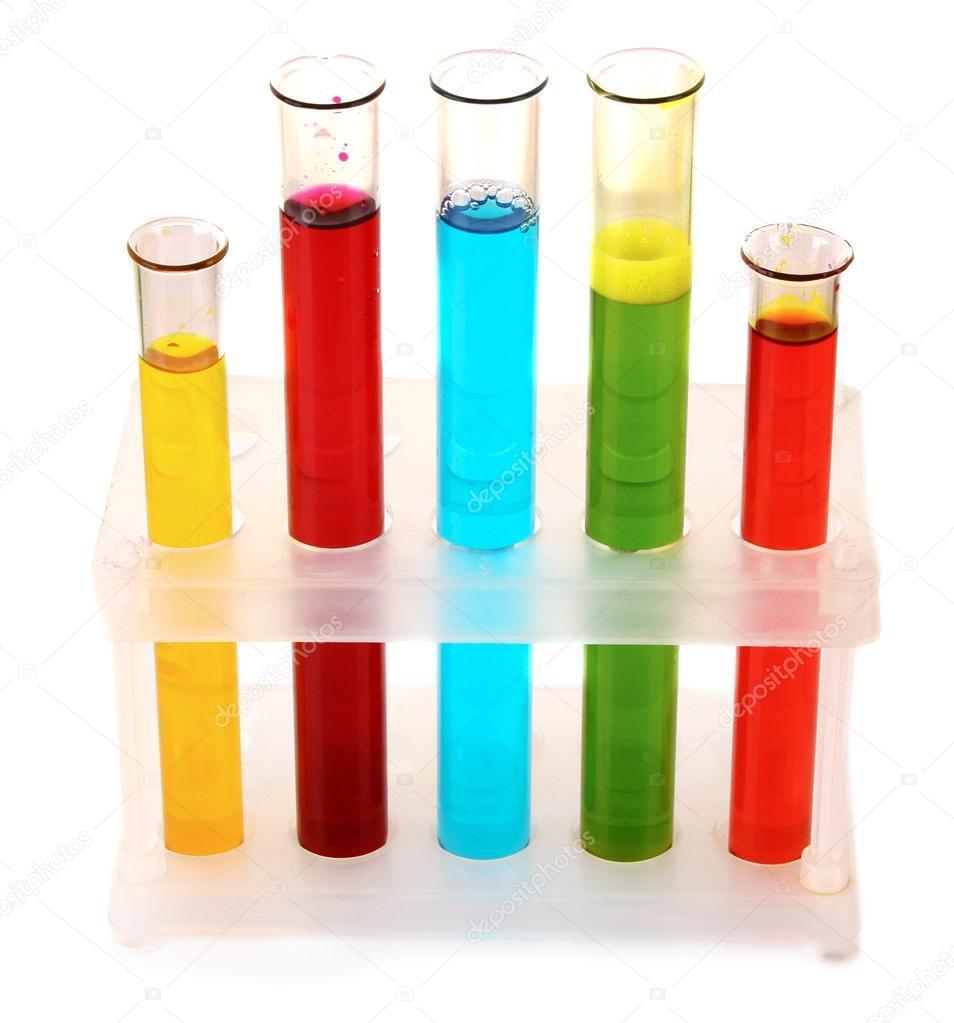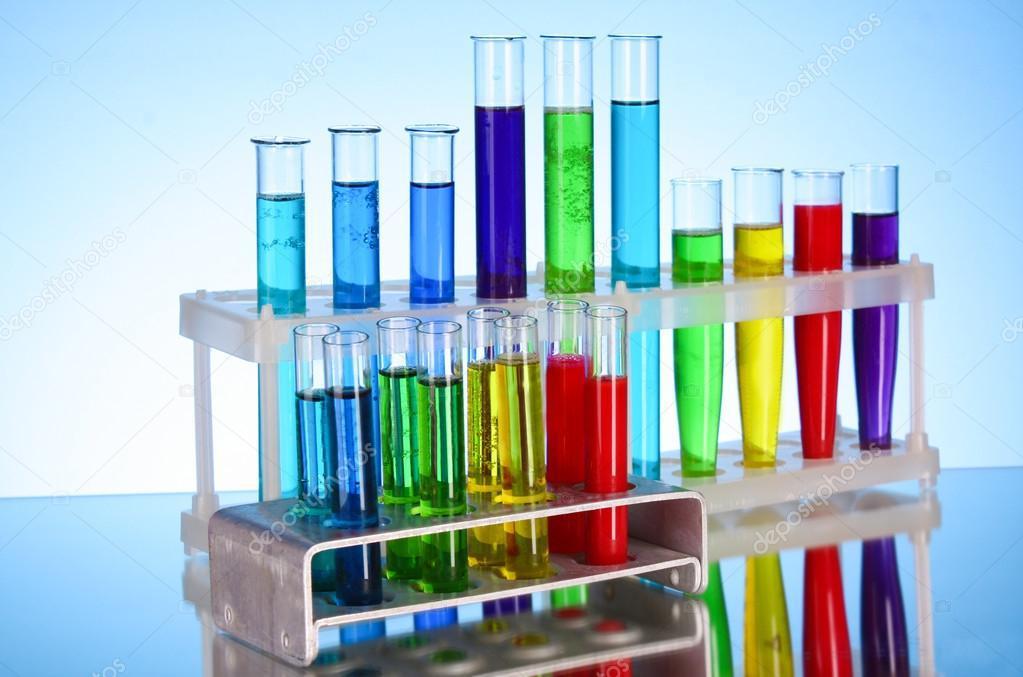The first image is the image on the left, the second image is the image on the right. Evaluate the accuracy of this statement regarding the images: "In one image there are five test tubes.". Is it true? Answer yes or no. Yes. The first image is the image on the left, the second image is the image on the right. Analyze the images presented: Is the assertion "There are five test tubes in the left image." valid? Answer yes or no. Yes. 